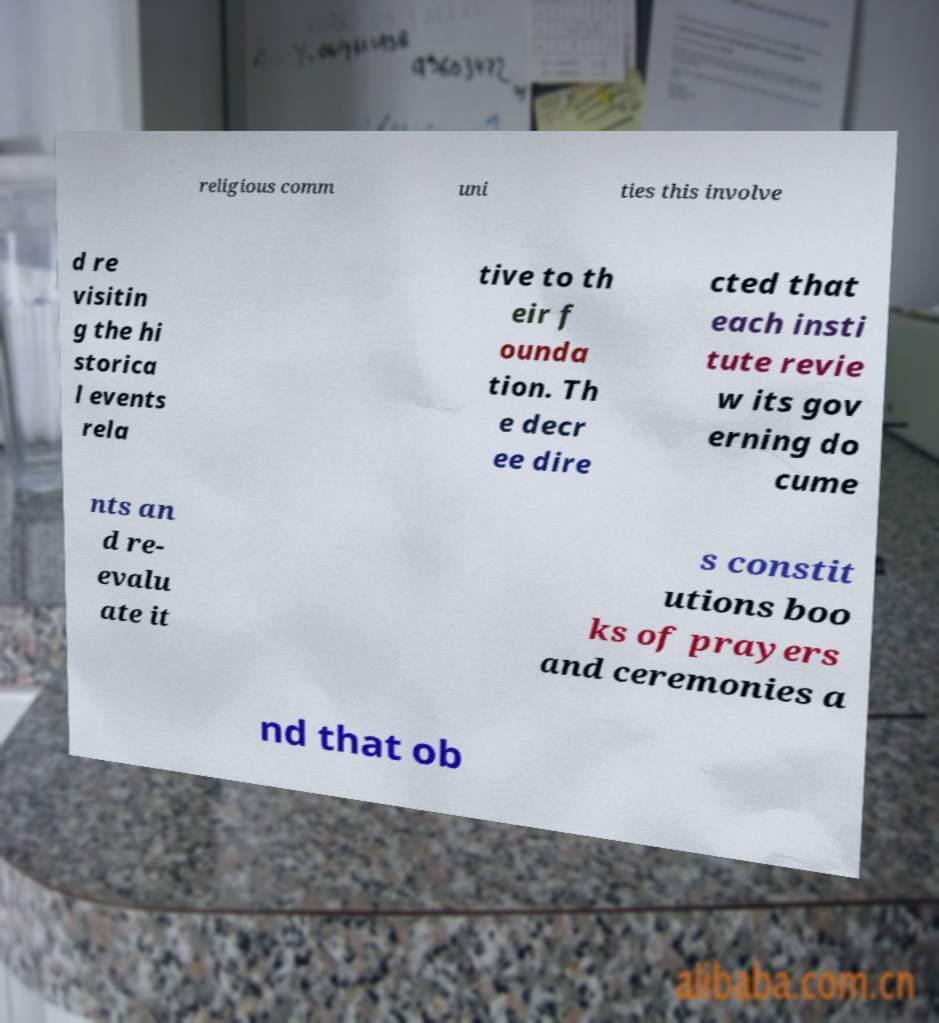Can you read and provide the text displayed in the image?This photo seems to have some interesting text. Can you extract and type it out for me? religious comm uni ties this involve d re visitin g the hi storica l events rela tive to th eir f ounda tion. Th e decr ee dire cted that each insti tute revie w its gov erning do cume nts an d re- evalu ate it s constit utions boo ks of prayers and ceremonies a nd that ob 